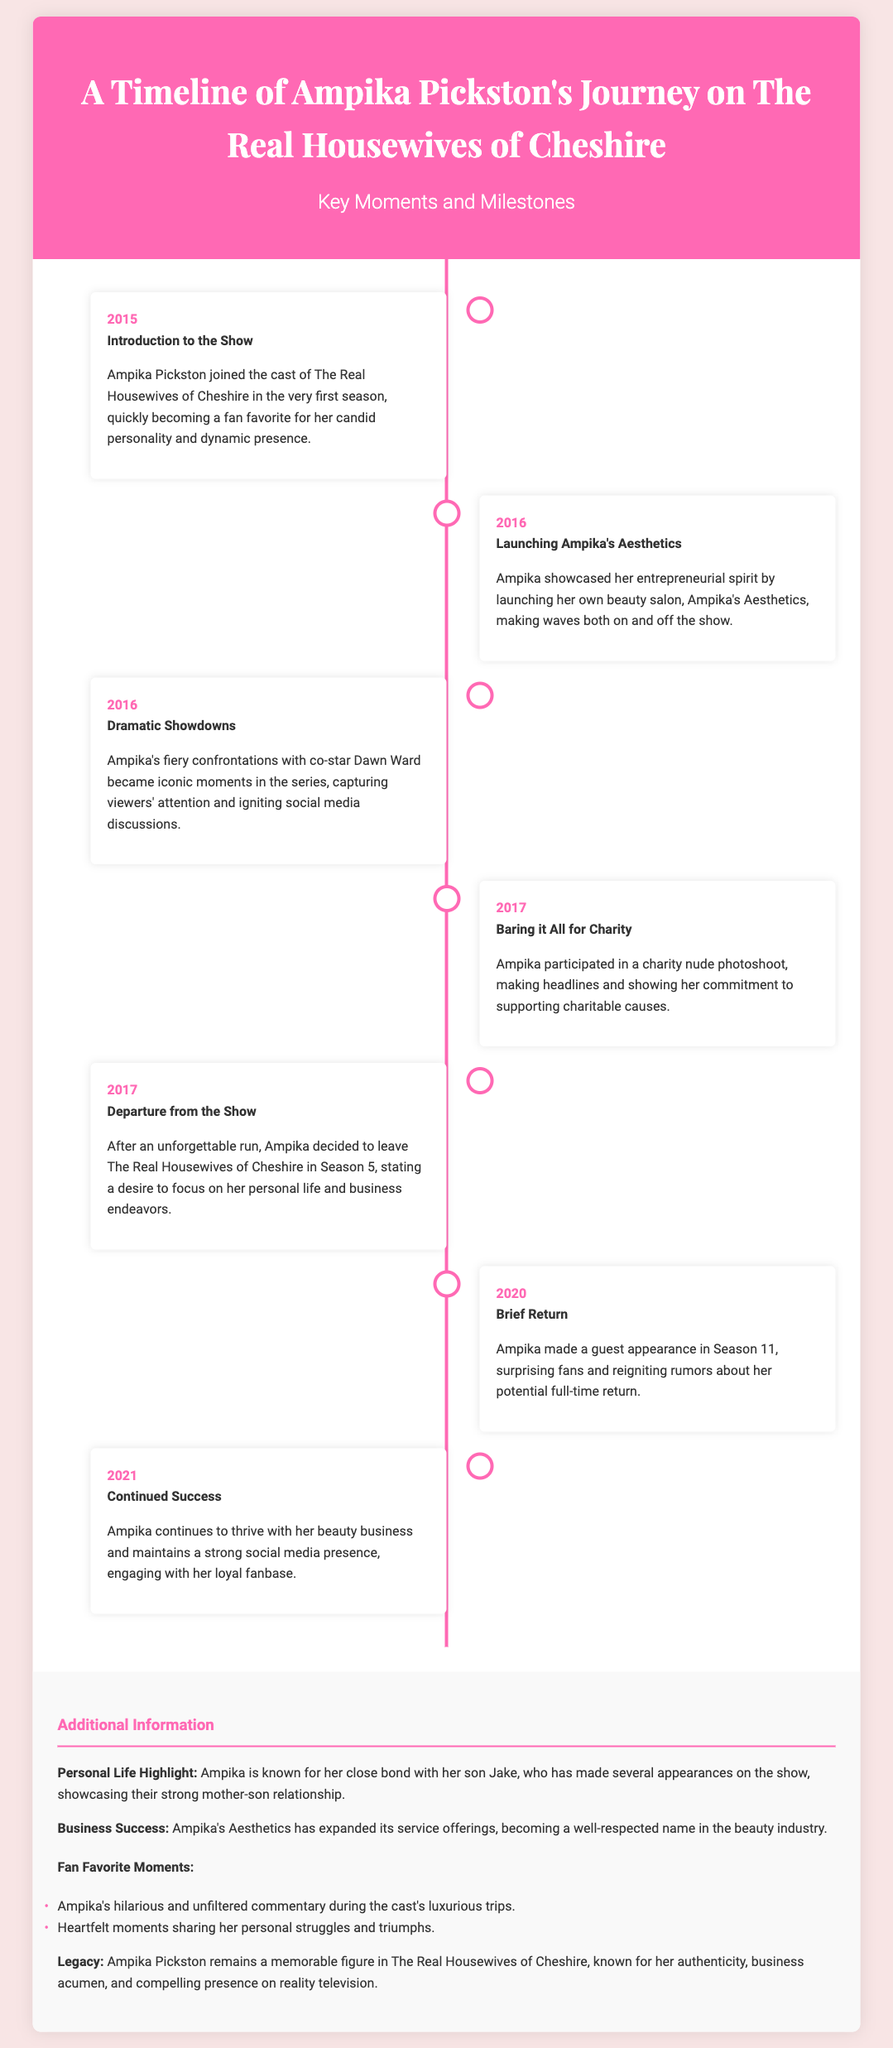What year did Ampika join the show? Ampika joined The Real Housewives of Cheshire in 2015, as indicated in the timeline section of the document.
Answer: 2015 What is the name of Ampika's beauty salon? The document mentions that she launched her own beauty salon named Ampika's Aesthetics.
Answer: Ampika's Aesthetics In which season did Ampika leave the show? The timeline states that she left in Season 5, indicating her departure year as 2017.
Answer: Season 5 What significant event took place in 2020? The document notes that in 2020, Ampika made a guest appearance in Season 11, highlighting her brief return.
Answer: Brief Return What was a key moment for Ampika in 2017? The event highlights her participation in a charity nude photoshoot, marking a significant moment in her journey.
Answer: Charity nude photoshoot Which co-star did Ampika have fiery confrontations with? The timeline specifies her dramatic showdowns with co-star Dawn Ward, which became iconic moments.
Answer: Dawn Ward What does Ampika's business focus on? The document details that Ampika's Aesthetics has expanded its service offerings, indicating its focus on beauty services.
Answer: Beauty services What relationship is highlighted in the additional information section? The additional information emphasizes Ampika's close bond with her son Jake, showcasing a significant personal aspect of her life.
Answer: Mother-son relationship What type of moments are listed as fan favorites? The document lists hilarious commentary and heartfelt moments as fan-favorite aspects of Ampika's presence on the show.
Answer: Hilarious commentary and heartfelt moments 